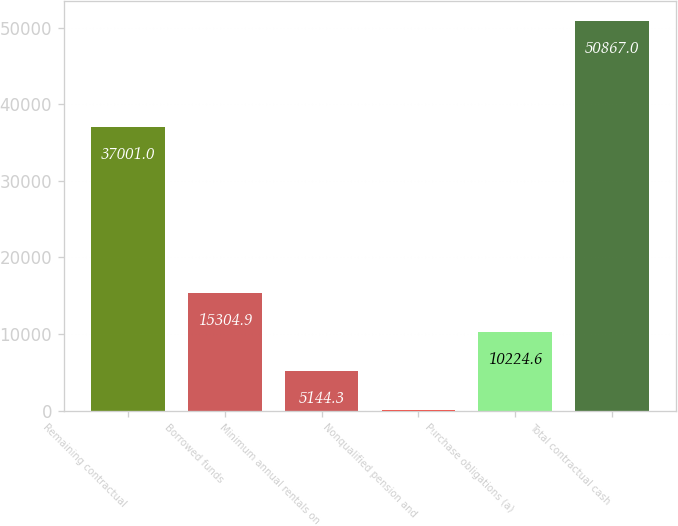Convert chart to OTSL. <chart><loc_0><loc_0><loc_500><loc_500><bar_chart><fcel>Remaining contractual<fcel>Borrowed funds<fcel>Minimum annual rentals on<fcel>Nonqualified pension and<fcel>Purchase obligations (a)<fcel>Total contractual cash<nl><fcel>37001<fcel>15304.9<fcel>5144.3<fcel>64<fcel>10224.6<fcel>50867<nl></chart> 